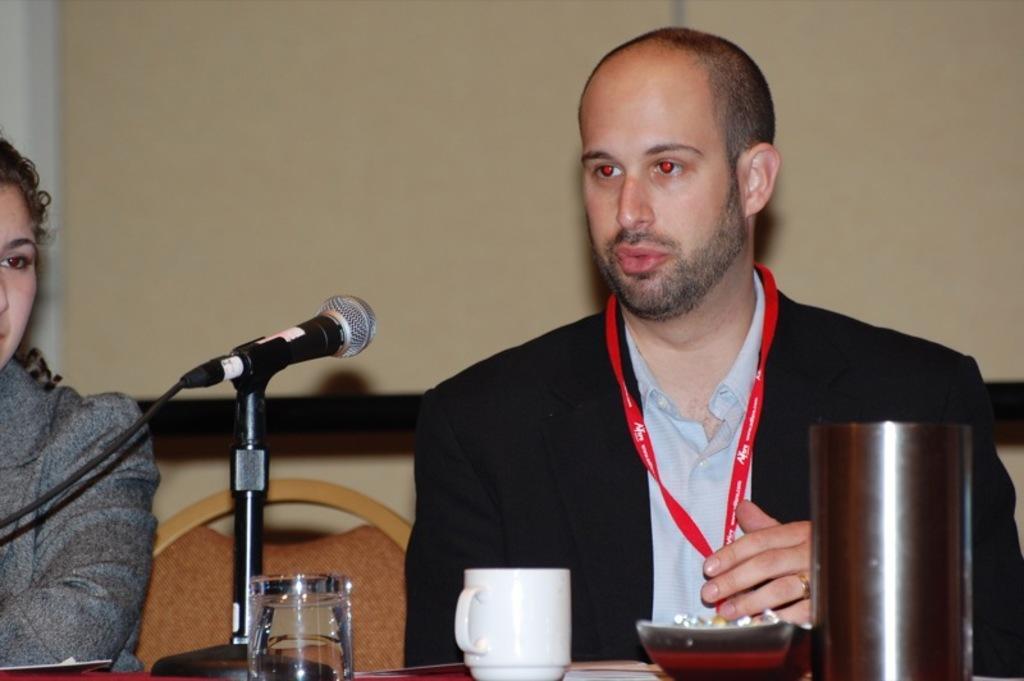In one or two sentences, can you explain what this image depicts? In this image we can see persons sitting on the chairs and a table is placed in front of them. On the table there are glass tumblers, food in the bowl, mic, cable and a beverage cup. 